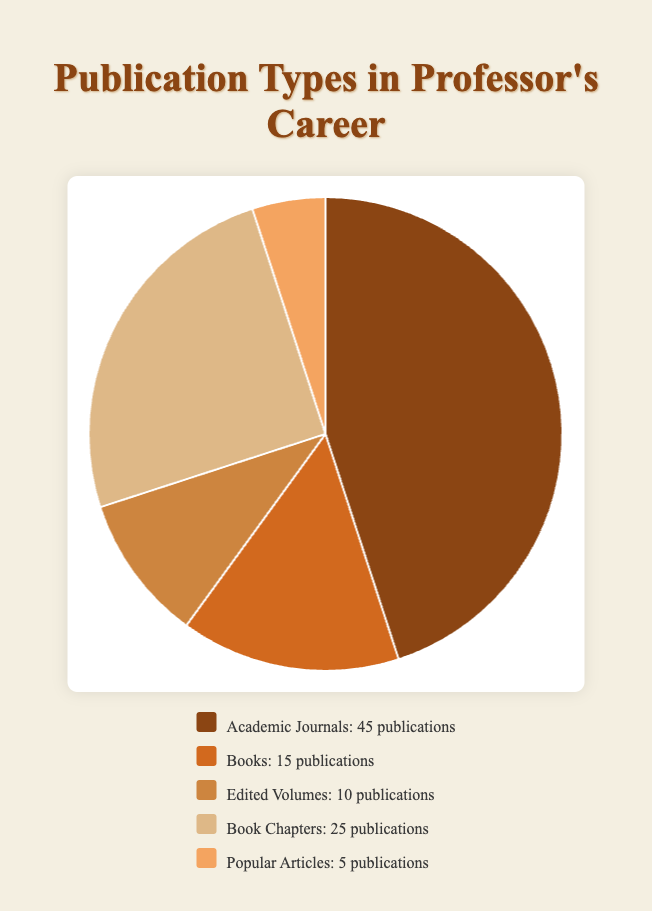What's the total number of publications the professor has? Sum all the publication counts: 45 (Academic Journals) + 15 (Books) + 10 (Edited Volumes) + 25 (Book Chapters) + 5 (Popular Articles) = 100
Answer: 100 Which type of publication is the least common in the professor's career? Look at the publication counts: Academic Journals (45), Books (15), Edited Volumes (10), Book Chapters (25), and Popular Articles (5). The least is 5.
Answer: Popular Articles What percentage of the professor's publications are Books? Divide the number of Books (15) by the total number of publications (100) and multiply by 100 to get the percentage: (15/100) * 100 = 15%
Answer: 15% How do Books compare to Edited Volumes in terms of publication count? Compare the counts of Books (15) and Edited Volumes (10). Books have more publications.
Answer: Books have more publications What's the difference in publication count between Academic Journals and Book Chapters? Subtract the number of Book Chapters (25) from Academic Journals (45): 45 - 25 = 20
Answer: 20 If combining Edited Volumes and Popular Articles, how does their total compare to the number of Books? Sum the counts of Edited Volumes (10) and Popular Articles (5): 10 + 5 = 15, which is equal to the count for Books (15)
Answer: Equal Which publication type represents a quarter of the total publications? Identify one-fourth of the total publications: 100 / 4 = 25. The number of Book Chapters is 25.
Answer: Book Chapters What is the combined publication count for Edited Volumes and Book Chapters? Sum the counts of Edited Volumes (10) and Book Chapters (25): 10 + 25 = 35
Answer: 35 What color represents Books on the pie chart? Look at the pie chart legend and find the color next to "Books". The color is identified in the provided data style: '#d2691e', which is sienna.
Answer: Sienna (brown) How many more Academic Journals has the professor published than Popular Articles? Subtract the number of Popular Articles (5) from Academic Journals (45): 45 - 5 = 40
Answer: 40 